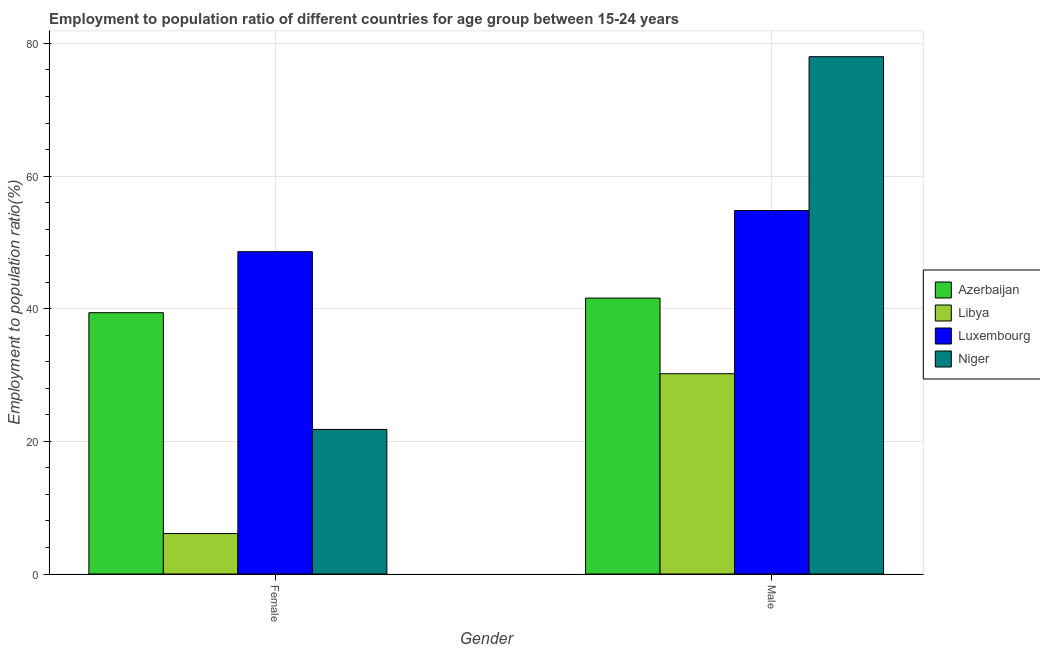How many groups of bars are there?
Provide a succinct answer. 2. Are the number of bars per tick equal to the number of legend labels?
Your answer should be very brief. Yes. How many bars are there on the 1st tick from the right?
Provide a succinct answer. 4. What is the label of the 1st group of bars from the left?
Keep it short and to the point. Female. What is the employment to population ratio(male) in Libya?
Offer a terse response. 30.2. Across all countries, what is the maximum employment to population ratio(male)?
Make the answer very short. 78. Across all countries, what is the minimum employment to population ratio(male)?
Keep it short and to the point. 30.2. In which country was the employment to population ratio(female) maximum?
Provide a short and direct response. Luxembourg. In which country was the employment to population ratio(female) minimum?
Offer a very short reply. Libya. What is the total employment to population ratio(female) in the graph?
Ensure brevity in your answer.  115.9. What is the difference between the employment to population ratio(female) in Niger and that in Libya?
Make the answer very short. 15.7. What is the difference between the employment to population ratio(female) in Azerbaijan and the employment to population ratio(male) in Luxembourg?
Provide a short and direct response. -15.4. What is the average employment to population ratio(male) per country?
Ensure brevity in your answer.  51.15. What is the difference between the employment to population ratio(male) and employment to population ratio(female) in Libya?
Offer a very short reply. 24.1. What is the ratio of the employment to population ratio(male) in Azerbaijan to that in Niger?
Provide a short and direct response. 0.53. Is the employment to population ratio(male) in Libya less than that in Niger?
Your response must be concise. Yes. What does the 2nd bar from the left in Male represents?
Provide a short and direct response. Libya. What does the 1st bar from the right in Female represents?
Give a very brief answer. Niger. How many bars are there?
Keep it short and to the point. 8. How many countries are there in the graph?
Your answer should be very brief. 4. Does the graph contain grids?
Offer a very short reply. Yes. How are the legend labels stacked?
Give a very brief answer. Vertical. What is the title of the graph?
Make the answer very short. Employment to population ratio of different countries for age group between 15-24 years. What is the Employment to population ratio(%) of Azerbaijan in Female?
Give a very brief answer. 39.4. What is the Employment to population ratio(%) in Libya in Female?
Your answer should be very brief. 6.1. What is the Employment to population ratio(%) in Luxembourg in Female?
Your response must be concise. 48.6. What is the Employment to population ratio(%) in Niger in Female?
Your response must be concise. 21.8. What is the Employment to population ratio(%) of Azerbaijan in Male?
Provide a short and direct response. 41.6. What is the Employment to population ratio(%) of Libya in Male?
Keep it short and to the point. 30.2. What is the Employment to population ratio(%) of Luxembourg in Male?
Keep it short and to the point. 54.8. Across all Gender, what is the maximum Employment to population ratio(%) of Azerbaijan?
Offer a very short reply. 41.6. Across all Gender, what is the maximum Employment to population ratio(%) of Libya?
Your answer should be compact. 30.2. Across all Gender, what is the maximum Employment to population ratio(%) in Luxembourg?
Provide a succinct answer. 54.8. Across all Gender, what is the minimum Employment to population ratio(%) of Azerbaijan?
Provide a short and direct response. 39.4. Across all Gender, what is the minimum Employment to population ratio(%) in Libya?
Your response must be concise. 6.1. Across all Gender, what is the minimum Employment to population ratio(%) in Luxembourg?
Provide a short and direct response. 48.6. Across all Gender, what is the minimum Employment to population ratio(%) in Niger?
Your response must be concise. 21.8. What is the total Employment to population ratio(%) of Libya in the graph?
Give a very brief answer. 36.3. What is the total Employment to population ratio(%) of Luxembourg in the graph?
Your answer should be compact. 103.4. What is the total Employment to population ratio(%) in Niger in the graph?
Offer a terse response. 99.8. What is the difference between the Employment to population ratio(%) in Azerbaijan in Female and that in Male?
Provide a short and direct response. -2.2. What is the difference between the Employment to population ratio(%) in Libya in Female and that in Male?
Give a very brief answer. -24.1. What is the difference between the Employment to population ratio(%) in Niger in Female and that in Male?
Provide a succinct answer. -56.2. What is the difference between the Employment to population ratio(%) in Azerbaijan in Female and the Employment to population ratio(%) in Luxembourg in Male?
Provide a succinct answer. -15.4. What is the difference between the Employment to population ratio(%) in Azerbaijan in Female and the Employment to population ratio(%) in Niger in Male?
Your answer should be very brief. -38.6. What is the difference between the Employment to population ratio(%) in Libya in Female and the Employment to population ratio(%) in Luxembourg in Male?
Provide a succinct answer. -48.7. What is the difference between the Employment to population ratio(%) in Libya in Female and the Employment to population ratio(%) in Niger in Male?
Keep it short and to the point. -71.9. What is the difference between the Employment to population ratio(%) of Luxembourg in Female and the Employment to population ratio(%) of Niger in Male?
Your answer should be compact. -29.4. What is the average Employment to population ratio(%) of Azerbaijan per Gender?
Offer a very short reply. 40.5. What is the average Employment to population ratio(%) in Libya per Gender?
Your response must be concise. 18.15. What is the average Employment to population ratio(%) in Luxembourg per Gender?
Keep it short and to the point. 51.7. What is the average Employment to population ratio(%) in Niger per Gender?
Offer a terse response. 49.9. What is the difference between the Employment to population ratio(%) in Azerbaijan and Employment to population ratio(%) in Libya in Female?
Provide a short and direct response. 33.3. What is the difference between the Employment to population ratio(%) in Azerbaijan and Employment to population ratio(%) in Luxembourg in Female?
Provide a short and direct response. -9.2. What is the difference between the Employment to population ratio(%) in Azerbaijan and Employment to population ratio(%) in Niger in Female?
Offer a very short reply. 17.6. What is the difference between the Employment to population ratio(%) in Libya and Employment to population ratio(%) in Luxembourg in Female?
Your response must be concise. -42.5. What is the difference between the Employment to population ratio(%) in Libya and Employment to population ratio(%) in Niger in Female?
Ensure brevity in your answer.  -15.7. What is the difference between the Employment to population ratio(%) in Luxembourg and Employment to population ratio(%) in Niger in Female?
Offer a terse response. 26.8. What is the difference between the Employment to population ratio(%) in Azerbaijan and Employment to population ratio(%) in Libya in Male?
Offer a very short reply. 11.4. What is the difference between the Employment to population ratio(%) of Azerbaijan and Employment to population ratio(%) of Niger in Male?
Ensure brevity in your answer.  -36.4. What is the difference between the Employment to population ratio(%) of Libya and Employment to population ratio(%) of Luxembourg in Male?
Your answer should be compact. -24.6. What is the difference between the Employment to population ratio(%) in Libya and Employment to population ratio(%) in Niger in Male?
Keep it short and to the point. -47.8. What is the difference between the Employment to population ratio(%) of Luxembourg and Employment to population ratio(%) of Niger in Male?
Your answer should be compact. -23.2. What is the ratio of the Employment to population ratio(%) in Azerbaijan in Female to that in Male?
Provide a succinct answer. 0.95. What is the ratio of the Employment to population ratio(%) in Libya in Female to that in Male?
Offer a terse response. 0.2. What is the ratio of the Employment to population ratio(%) of Luxembourg in Female to that in Male?
Offer a very short reply. 0.89. What is the ratio of the Employment to population ratio(%) of Niger in Female to that in Male?
Provide a short and direct response. 0.28. What is the difference between the highest and the second highest Employment to population ratio(%) in Azerbaijan?
Ensure brevity in your answer.  2.2. What is the difference between the highest and the second highest Employment to population ratio(%) in Libya?
Your response must be concise. 24.1. What is the difference between the highest and the second highest Employment to population ratio(%) of Niger?
Your response must be concise. 56.2. What is the difference between the highest and the lowest Employment to population ratio(%) of Azerbaijan?
Keep it short and to the point. 2.2. What is the difference between the highest and the lowest Employment to population ratio(%) in Libya?
Ensure brevity in your answer.  24.1. What is the difference between the highest and the lowest Employment to population ratio(%) of Luxembourg?
Ensure brevity in your answer.  6.2. What is the difference between the highest and the lowest Employment to population ratio(%) in Niger?
Give a very brief answer. 56.2. 